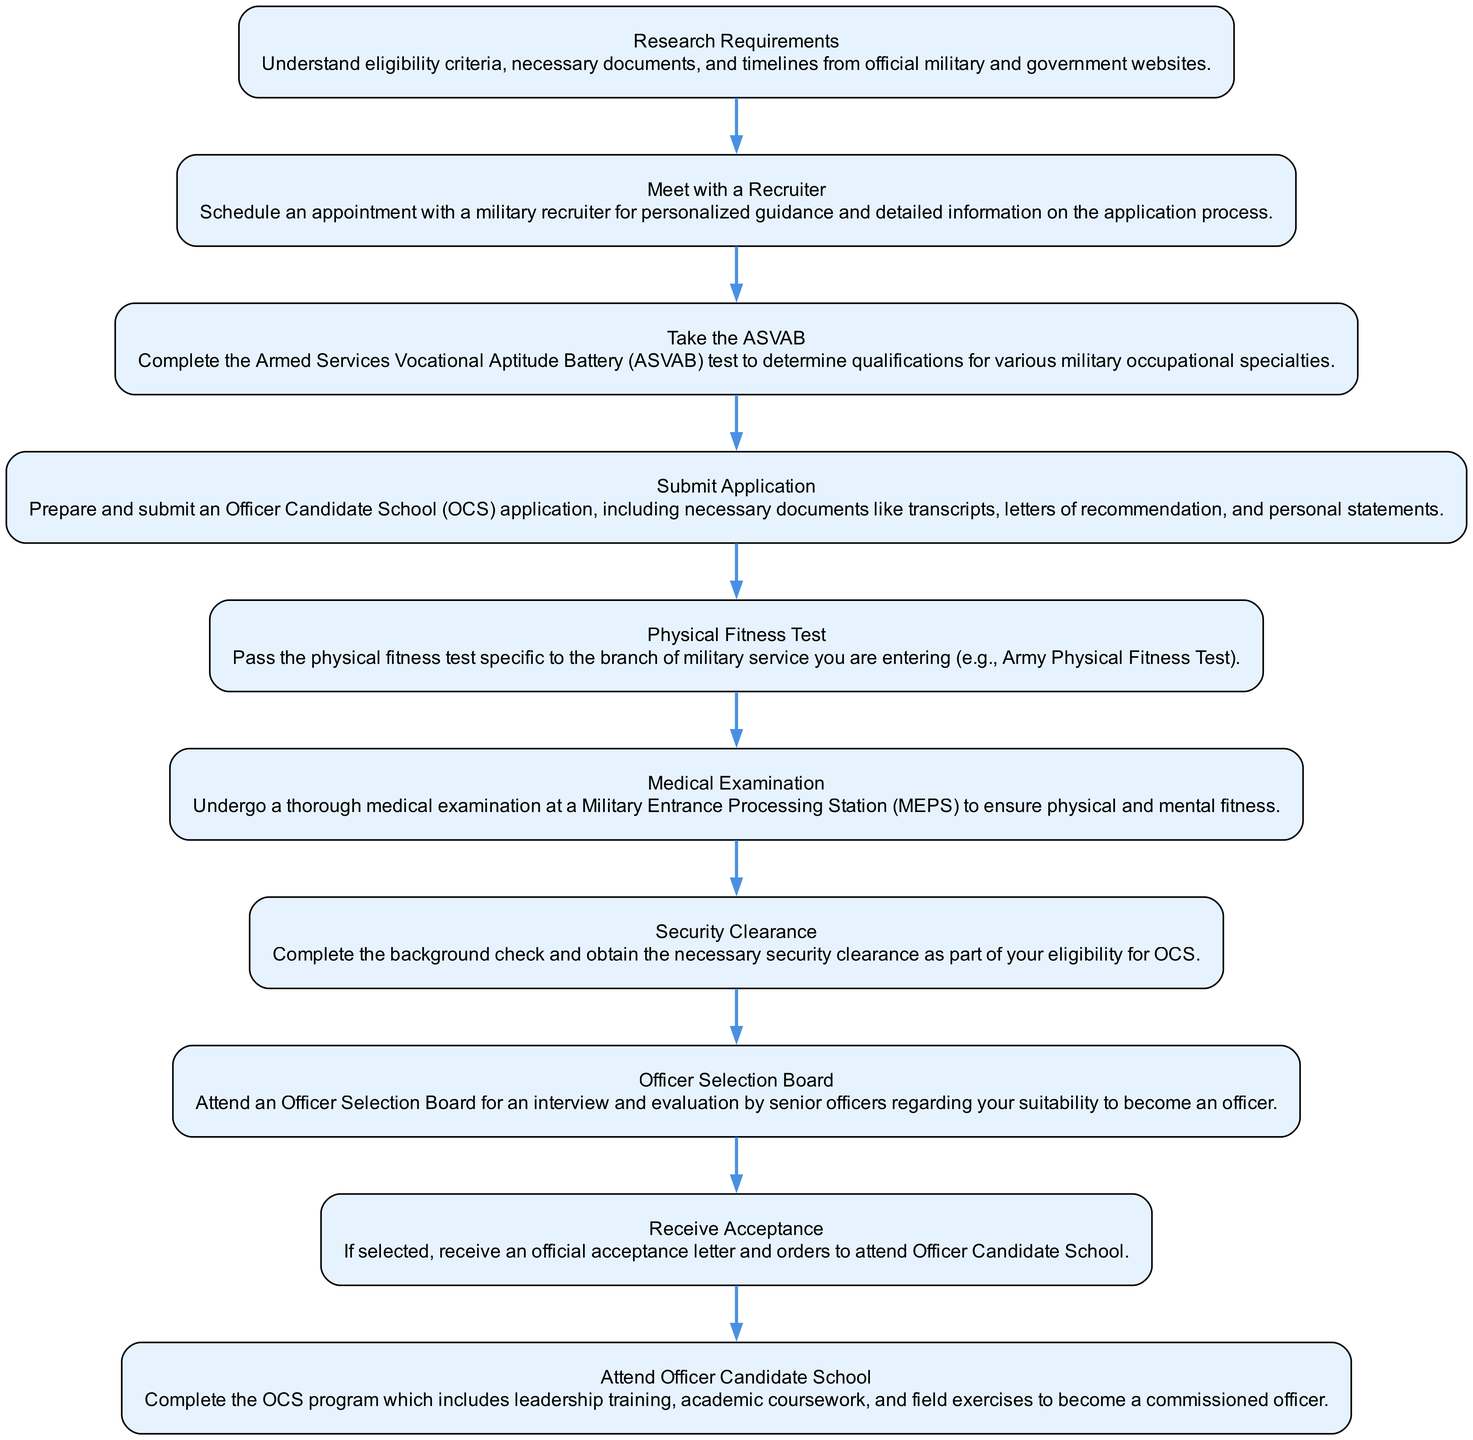What is the first stage in the application process? The first stage in the diagram is labeled "Research Requirements." It appears at the top of the flow chart as the starting point for the entire application process.
Answer: Research Requirements How many total stages are there in the application process? By counting the number of distinct stages represented in the diagram, I observe there are ten stages listed sequentially from start to finish.
Answer: Ten What is the last stage before attending Officer Candidate School? The last stage before attending Officer Candidate School is "Receive Acceptance," which directly precedes the stage "Attend Officer Candidate School."
Answer: Receive Acceptance What must be completed immediately after submitting the application? According to the diagram, immediately after submitting the application, you are required to pass the Physical Fitness Test, as this stage follows the submission stage.
Answer: Physical Fitness Test What does the Officer Selection Board stage involve? The Officer Selection Board stage involves attending an interview and evaluation by senior officers, as indicated in the description of this specific stage in the diagram.
Answer: Interview and evaluation What type of examination is required in the application process? The application process includes a "Medical Examination," which involves a thorough evaluation to ensure physical and mental fitness.
Answer: Medical Examination Which stage requires a background check? The stage that requires a background check in the diagram is "Security Clearance," which is essential for eligibility for Officer Candidate School.
Answer: Security Clearance What is the immediate prerequisite for the "Attend Officer Candidate School" stage? Before attending Officer Candidate School, the prerequisite is to receive an acceptance letter, as indicated in the flow from "Receive Acceptance" to "Attend Officer Candidate School."
Answer: Receive Acceptance What is the main purpose of the ASVAB in the application process? The ASVAB is taken to determine qualifications for various military occupational specialties, serving as a key assessment test in the application process.
Answer: Determine qualifications 